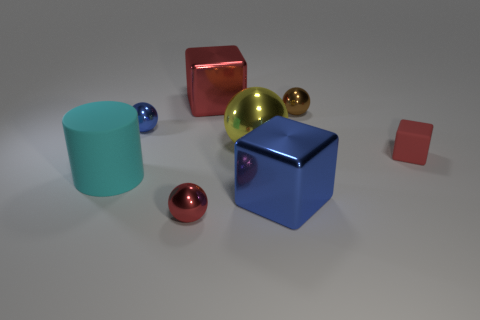Does the image suggest any particular theme or concept? The image could be interpreted as an exploration of geometry and color in three-dimensional space. It masterfully demonstrates the way light interacts with different surfaces—some materials reflect light, like the metallic spheres, while others, like the matte cubes, absorb light. This could symbolize contrasts, such as the tension between opulence and simplicity or how different entities coexist in a shared space. 